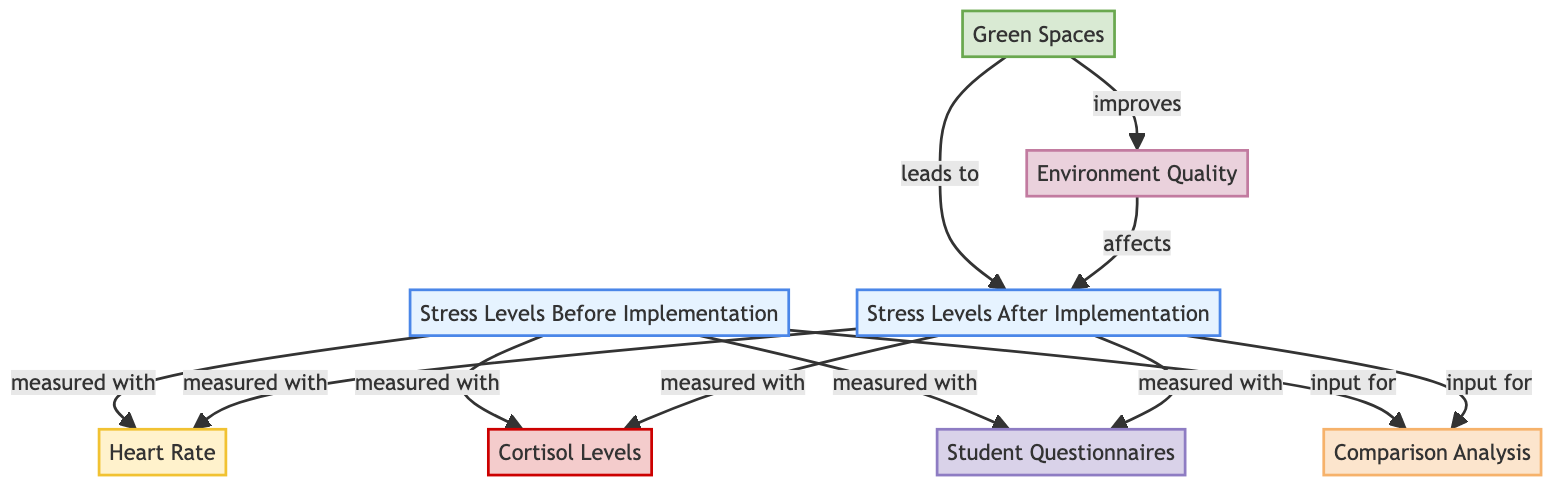What are the two measurements for stress levels before implementation? The diagram shows that stress levels before implementation were measured with heart rate and cortisol levels. These are the links from the "Stress Levels Before Implementation" node to the "Heart Rate" and "Cortisol Levels" nodes.
Answer: Heart Rate, Cortisol Levels What leads to the stress levels after implementation? The diagram indicates that green spaces lead to stress levels after implementation. This is shown by the arrow connecting the "Green Spaces" node to the "Stress Levels After Implementation" node.
Answer: Green Spaces How many nodes represent measurements? In the diagram, there are three measurement nodes: Heart Rate, Cortisol Levels, and Student Questionnaires. These are the nodes that provide data regarding stress levels.
Answer: 3 What is the relationship between environment quality and stress levels after implementation? The diagram illustrates that environment quality improves stress levels after implementation. The arrow from the "Environment Quality" node points to the "Stress Levels After Implementation" node.
Answer: Improves Which two sets of measurements apply to stress levels after implementation? The diagram specifies that stress levels after implementation were also measured with heart rate and cortisol levels, similar to the previous state, plus student questionnaires. This is noted in the connections from the "Stress Levels After Implementation" node.
Answer: Heart Rate, Cortisol Levels, Student Questionnaires What type of analysis combines inputs from stress levels before and after implementation? The diagram indicates that there is a comparison analysis that takes into account both the stress levels before and after implementation. This can be seen in the links from both stress levels nodes to the "Comparison Analysis" node.
Answer: Comparison Analysis 